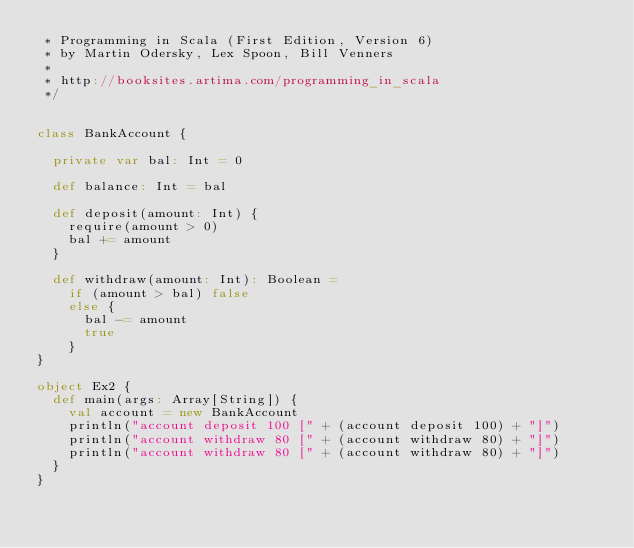Convert code to text. <code><loc_0><loc_0><loc_500><loc_500><_Scala_> * Programming in Scala (First Edition, Version 6)
 * by Martin Odersky, Lex Spoon, Bill Venners
 *
 * http://booksites.artima.com/programming_in_scala
 */


class BankAccount {

  private var bal: Int = 0

  def balance: Int = bal

  def deposit(amount: Int) {
    require(amount > 0)
    bal += amount
  }

  def withdraw(amount: Int): Boolean = 
    if (amount > bal) false
    else {
      bal -= amount
      true
    }
} 

object Ex2 {
  def main(args: Array[String]) {
    val account = new BankAccount
    println("account deposit 100 [" + (account deposit 100) + "]")
    println("account withdraw 80 [" + (account withdraw 80) + "]")
    println("account withdraw 80 [" + (account withdraw 80) + "]")
  }
}
</code> 